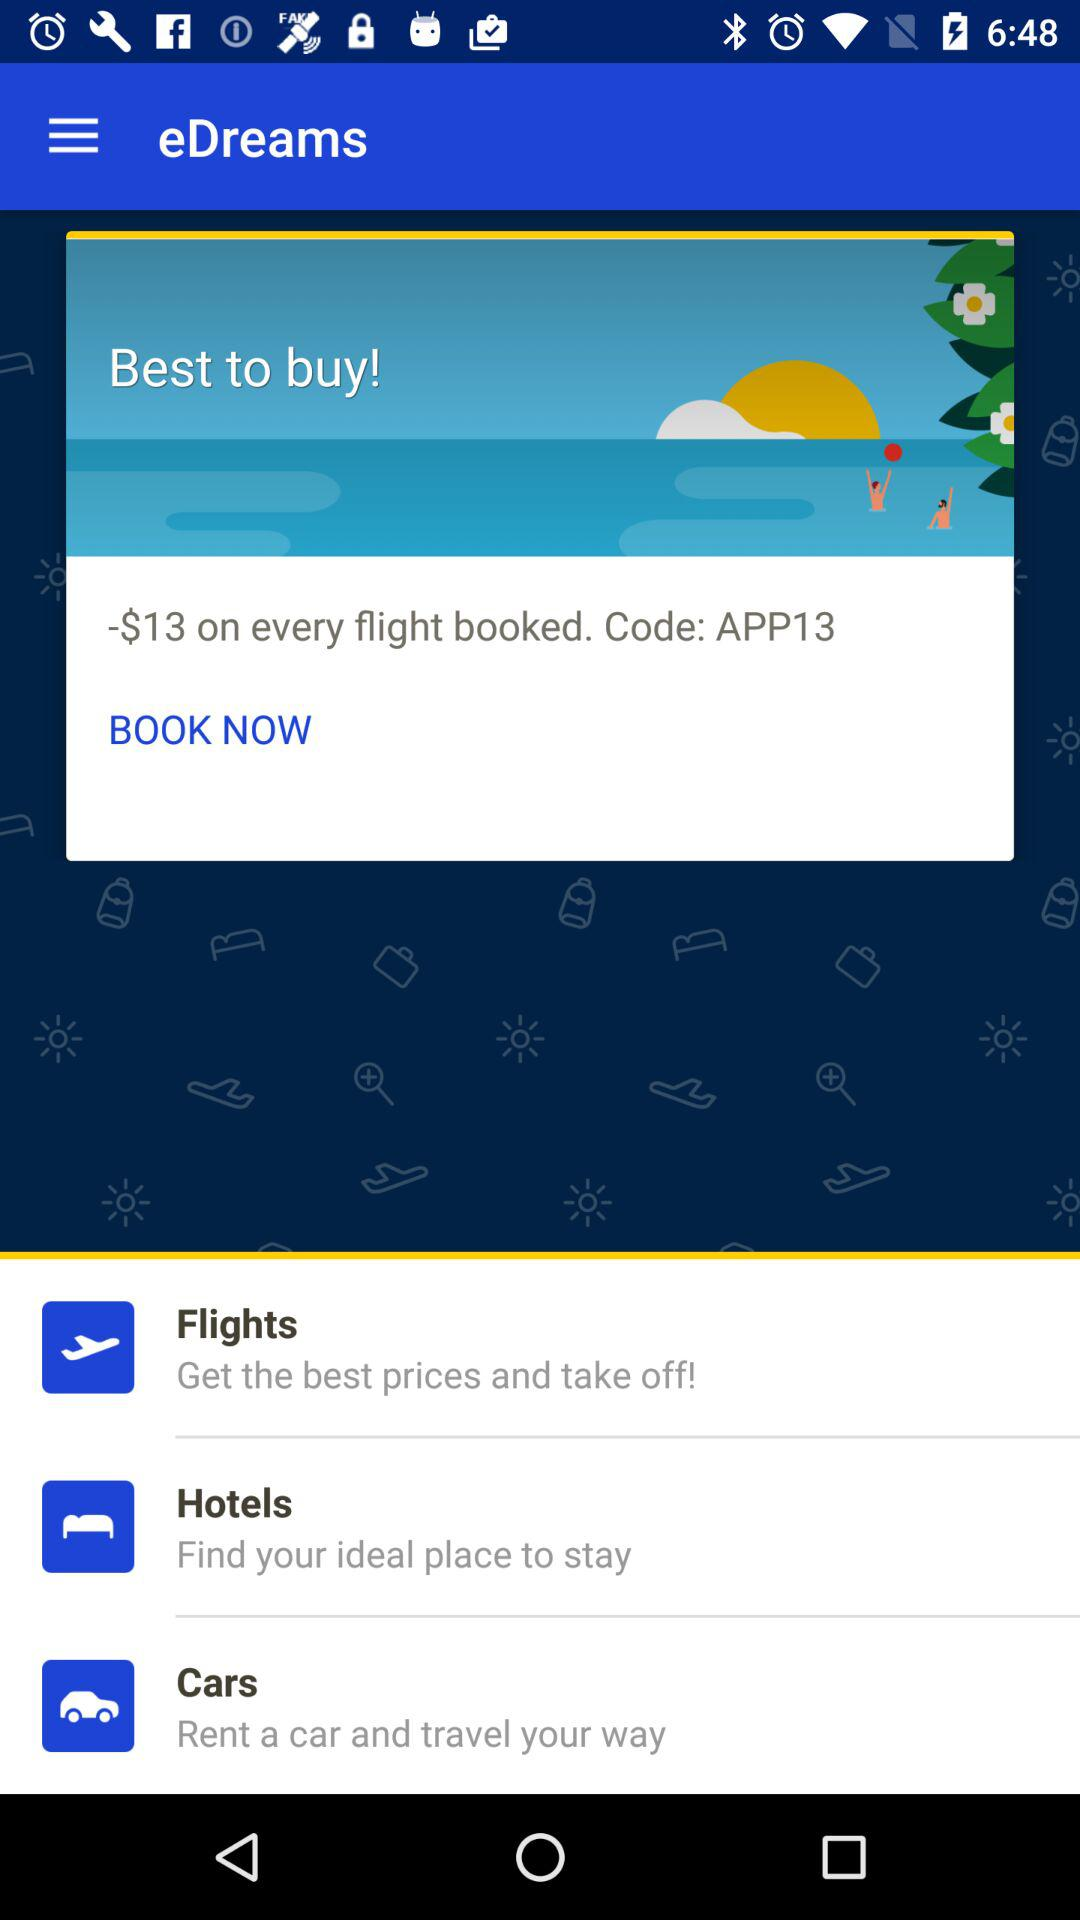What is the best offer to buy? The best offer is $13 on every flight booked. 